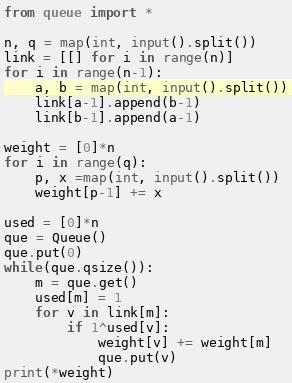Convert code to text. <code><loc_0><loc_0><loc_500><loc_500><_Python_>from queue import *

n, q = map(int, input().split())
link = [[] for i in range(n)]
for i in range(n-1):
	a, b = map(int, input().split())
	link[a-1].append(b-1)
	link[b-1].append(a-1)

weight = [0]*n
for i in range(q):
	p, x =map(int, input().split())
	weight[p-1] += x

used = [0]*n
que = Queue()
que.put(0)
while(que.qsize()):
	m = que.get()
	used[m] = 1
	for v in link[m]:
		if 1^used[v]:
			weight[v] += weight[m]
			que.put(v)
print(*weight)</code> 